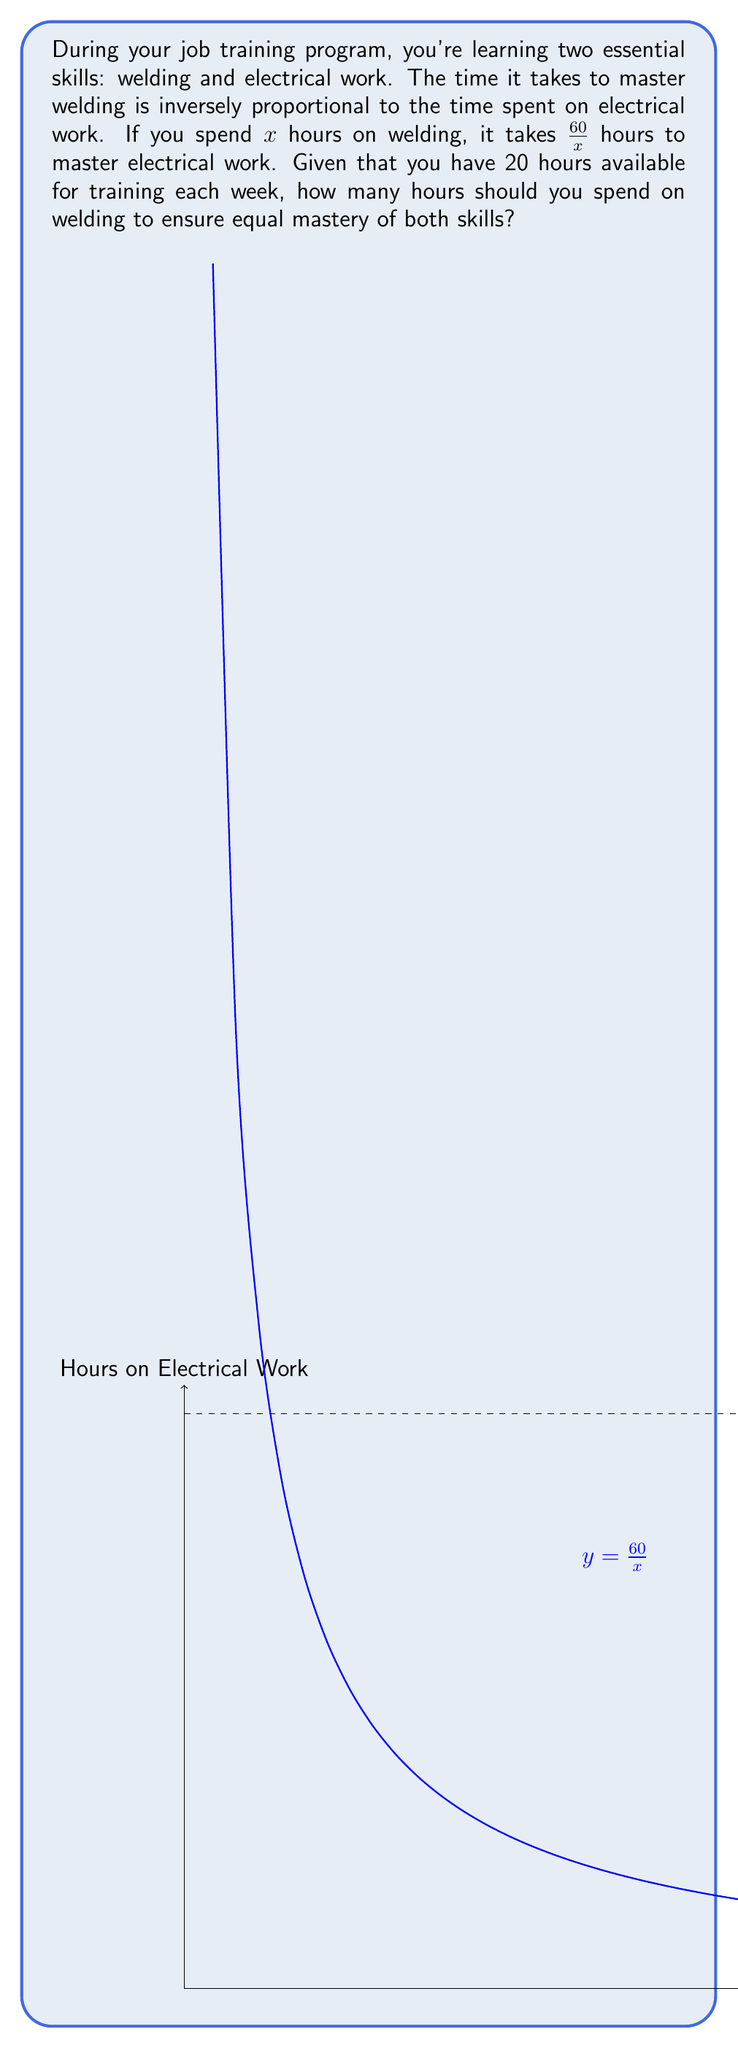Can you solve this math problem? Let's approach this step-by-step:

1) Let $x$ be the number of hours spent on welding.

2) The time spent on electrical work is given by $\frac{60}{x}$ hours.

3) For equal mastery, the time spent on welding should equal the time spent on electrical work:

   $$x = \frac{60}{x}$$

4) Given that you have 20 hours available each week, we can set up the equation:

   $$x + \frac{60}{x} = 20$$

5) Multiply both sides by $x$:

   $$x^2 + 60 = 20x$$

6) Rearrange to standard quadratic form:

   $$x^2 - 20x + 60 = 0$$

7) Use the quadratic formula: $x = \frac{-b \pm \sqrt{b^2 - 4ac}}{2a}$

   Where $a=1$, $b=-20$, and $c=60$

8) Plugging in:

   $$x = \frac{20 \pm \sqrt{400 - 240}}{2} = \frac{20 \pm \sqrt{160}}{2} = \frac{20 \pm 4\sqrt{10}}{2}$$

9) Simplify:

   $$x = 10 \pm 2\sqrt{10}$$

10) Since time can't be negative, we take the positive root:

    $$x = 10 + 2\sqrt{10} \approx 16.32$$

Therefore, you should spend approximately 16.32 hours on welding (and consequently, 3.68 hours on electrical work) to ensure equal mastery of both skills.
Answer: $10 + 2\sqrt{10}$ hours (≈ 16.32 hours) 